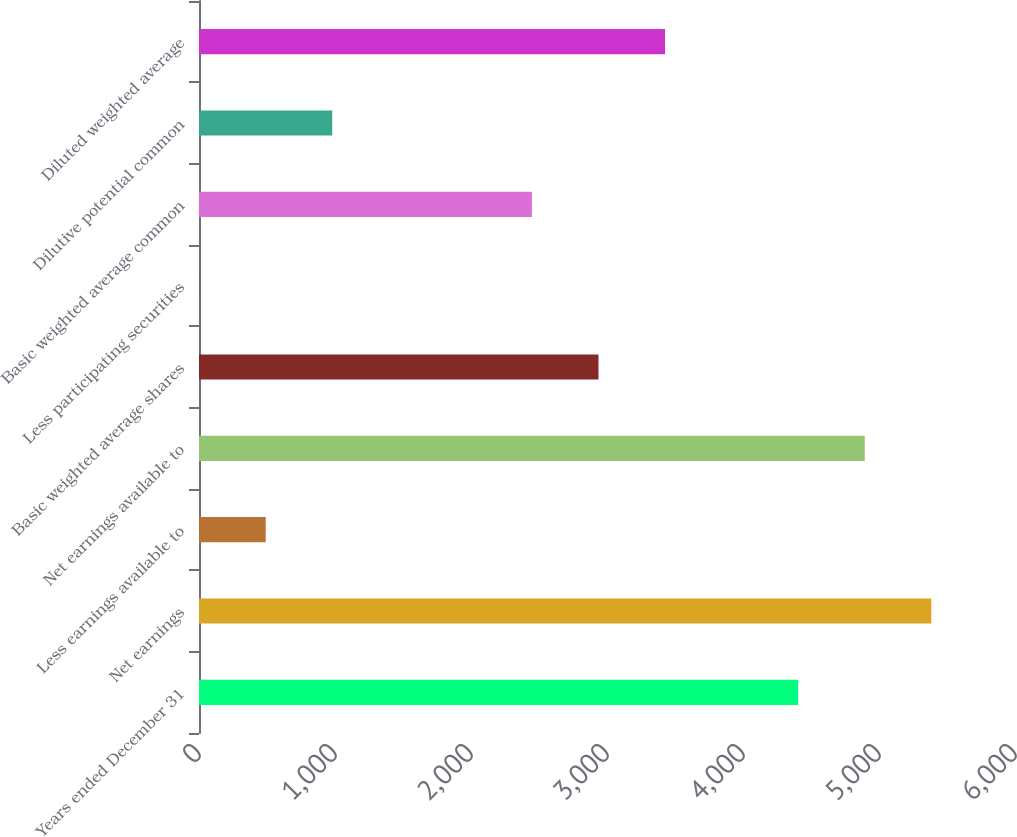Convert chart. <chart><loc_0><loc_0><loc_500><loc_500><bar_chart><fcel>Years ended December 31<fcel>Net earnings<fcel>Less earnings available to<fcel>Net earnings available to<fcel>Basic weighted average shares<fcel>Less participating securities<fcel>Basic weighted average common<fcel>Dilutive potential common<fcel>Diluted weighted average<nl><fcel>4405.6<fcel>5384.4<fcel>490.4<fcel>4895<fcel>2937.4<fcel>1<fcel>2448<fcel>979.8<fcel>3426.8<nl></chart> 